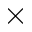<formula> <loc_0><loc_0><loc_500><loc_500>\times</formula> 